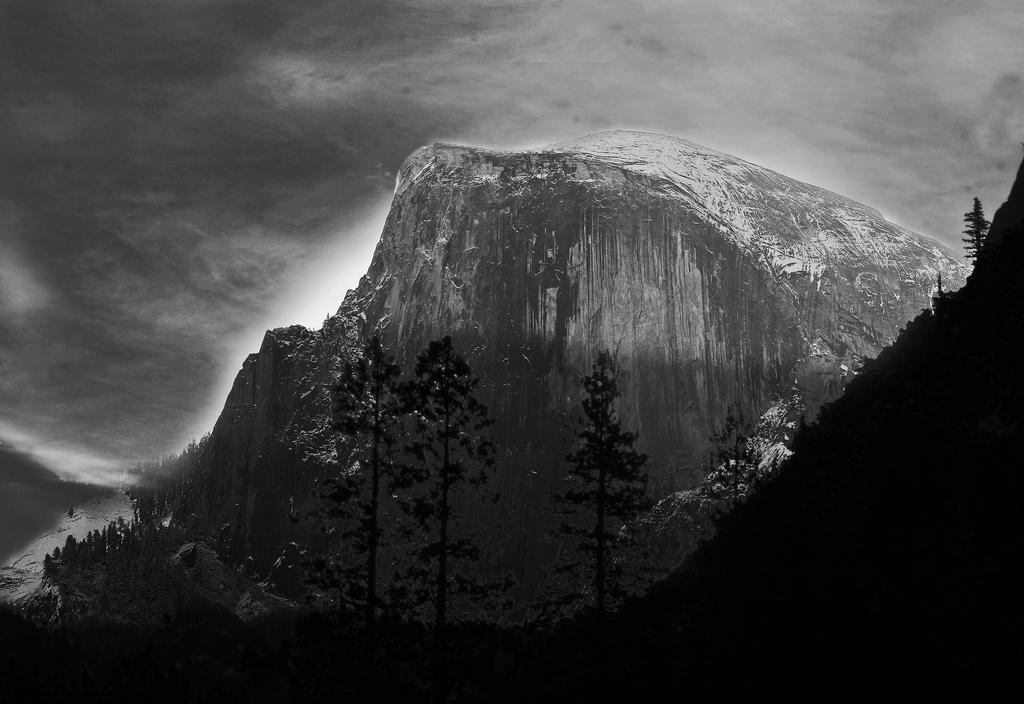What is the main geographical feature in the picture? There is a mountain in the picture. What type of vegetation can be seen in the picture? There are trees in the picture. How would you describe the weather in the picture? The sky is cloudy in the picture. What type of structure can be seen near the mountain in the picture? There is no structure visible near the mountain in the picture. How many boats are present in the picture? There are no boats present in the picture. 